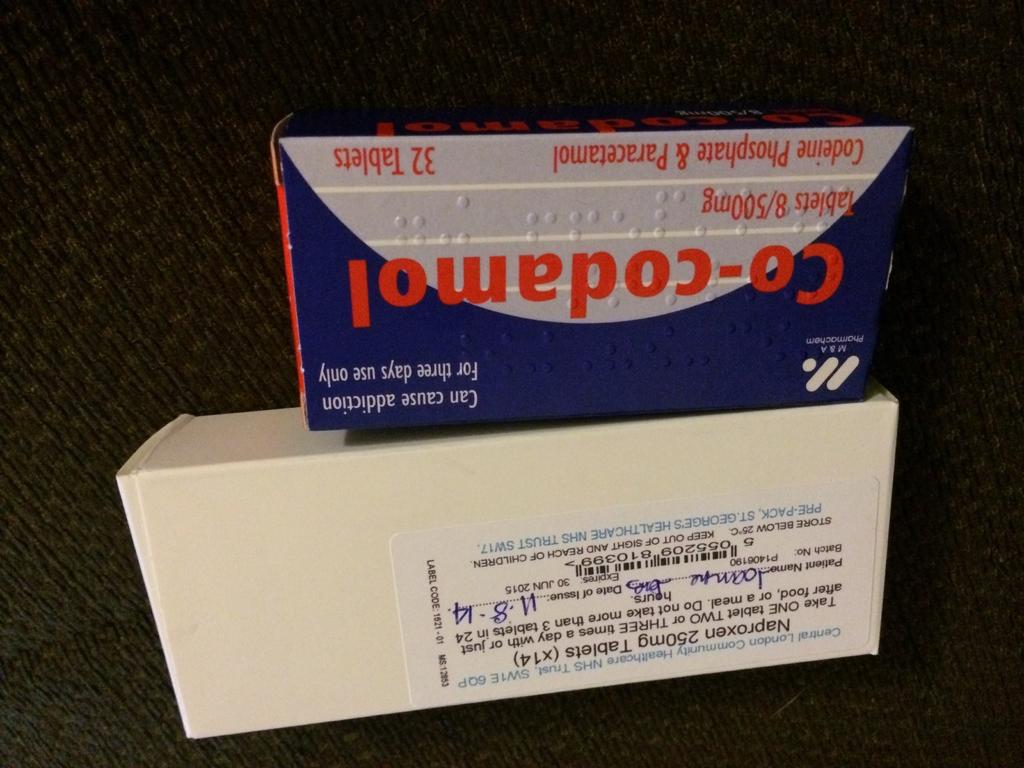How many tablets are in the blue box?
Make the answer very short. 32. How many mg is the medication in the blue box?
Make the answer very short. 500. 